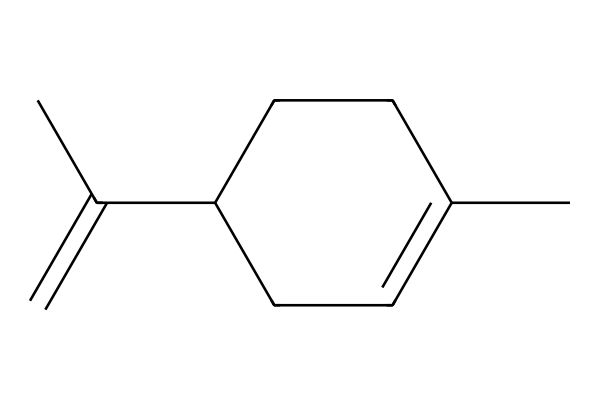How many carbon atoms are in limonene? By examining the SMILES representation, "CC1=CCC(CC1)C(=C)C", we can count the carbon atoms present in the structure. Each 'C' denotes a carbon atom; counting them gives us a total of ten carbon atoms in limonene.
Answer: ten What is the degree of unsaturation in limonene? To find the degree of unsaturation, we can apply the formula (2C + 2 + N - H - X) / 2. Here, C = 10, H = 16 (since the structure must maintain its saturation balance), N = 0, and X = 0. Plugging the values into the formula gives us (2(10) + 2 - 16) / 2 = 3. This indicates the presence of three degrees of unsaturation, which typically correspond to double bonds or rings.
Answer: three How many double bonds are present in the structure? From the SMILES representation, we observe that the "C(=C)" indicates a double bond between two carbon atoms. Counting other features in the cyclical and linear parts shows that there is only one double bond present in the structure of limonene.
Answer: one What functional group is likely present in limonene? Limonene is known to be a terpene, characterized by its presence of a double bond and is often associated with alkenes in its structure. The double bond (C=C) seen in the representation suggests that limonene falls under the class of alkenes, which are compounds containing one or more carbon-carbon double bonds.
Answer: alkene Is limonene a saturated or unsaturated compound? The presence of a double bond in the structure indicates that limonene has not filled all its hydrogen atoms to maximum capacity, thus classifying it as an unsaturated compound. The presence of a degree of unsaturation also supports this classification.
Answer: unsaturated How many rings are present in the molecular structure of limonene? Analyzing the structure, we can identify a cycloalkane due to the "C1" notation in the SMILES, which signifies the start and end of a ring. In this case, we see one complete ring in the structure of limonene, confirming its cyclic nature.
Answer: one 